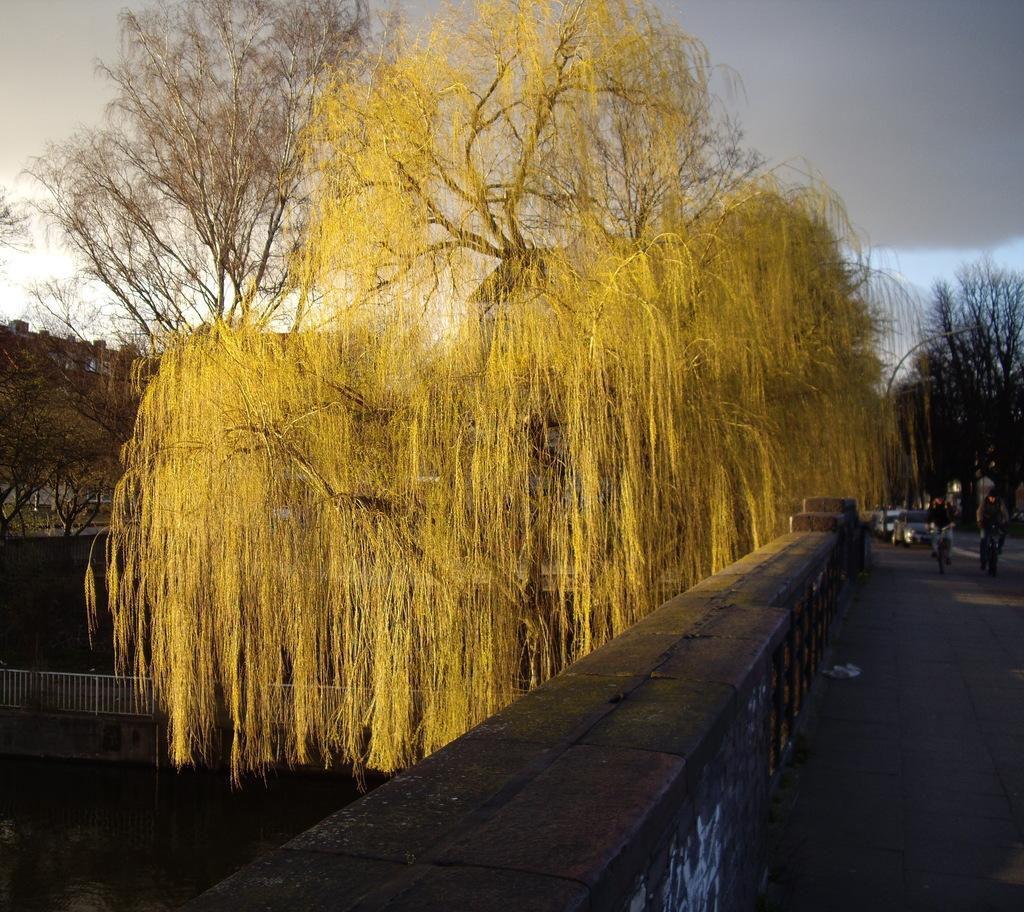In one or two sentences, can you explain what this image depicts? In the center of the image we can see a group of trees. On the right side of the image we can see some people riding bicycles, some cars are parked on the road and a light pole. In the left side of the image we can see barricade, building with windows. At the top of the image we can see the sky. 